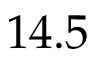<formula> <loc_0><loc_0><loc_500><loc_500>1 4 . 5</formula> 